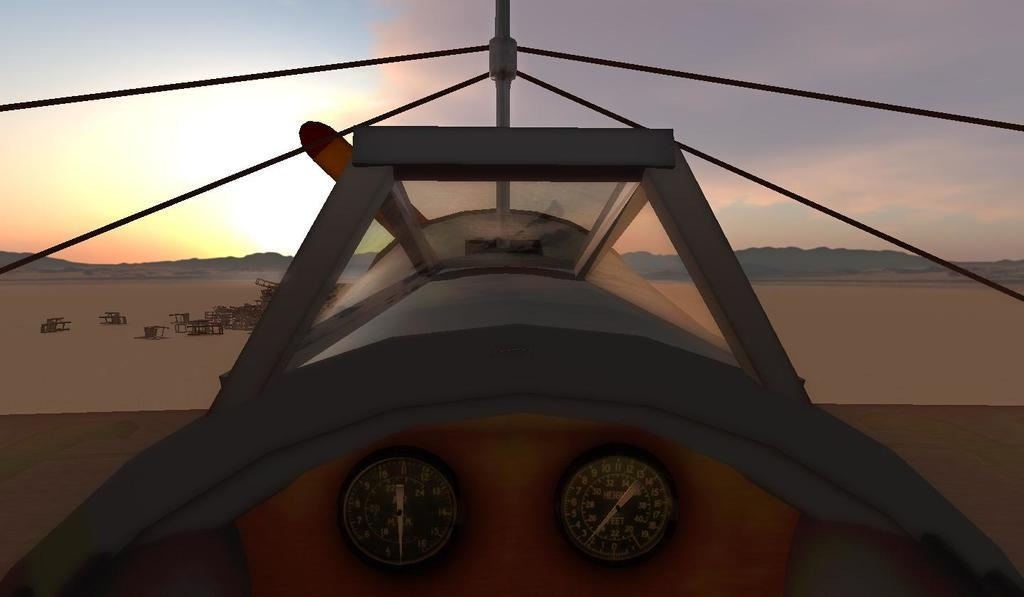<image>
Create a compact narrative representing the image presented. An airplane has a gauge that shows the needle pointing to 2. 